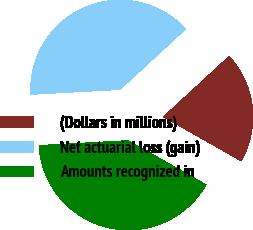Convert chart. <chart><loc_0><loc_0><loc_500><loc_500><pie_chart><fcel>(Dollars in millions)<fcel>Net actuarial loss (gain)<fcel>Amounts recognized in<nl><fcel>20.06%<fcel>39.02%<fcel>40.92%<nl></chart> 